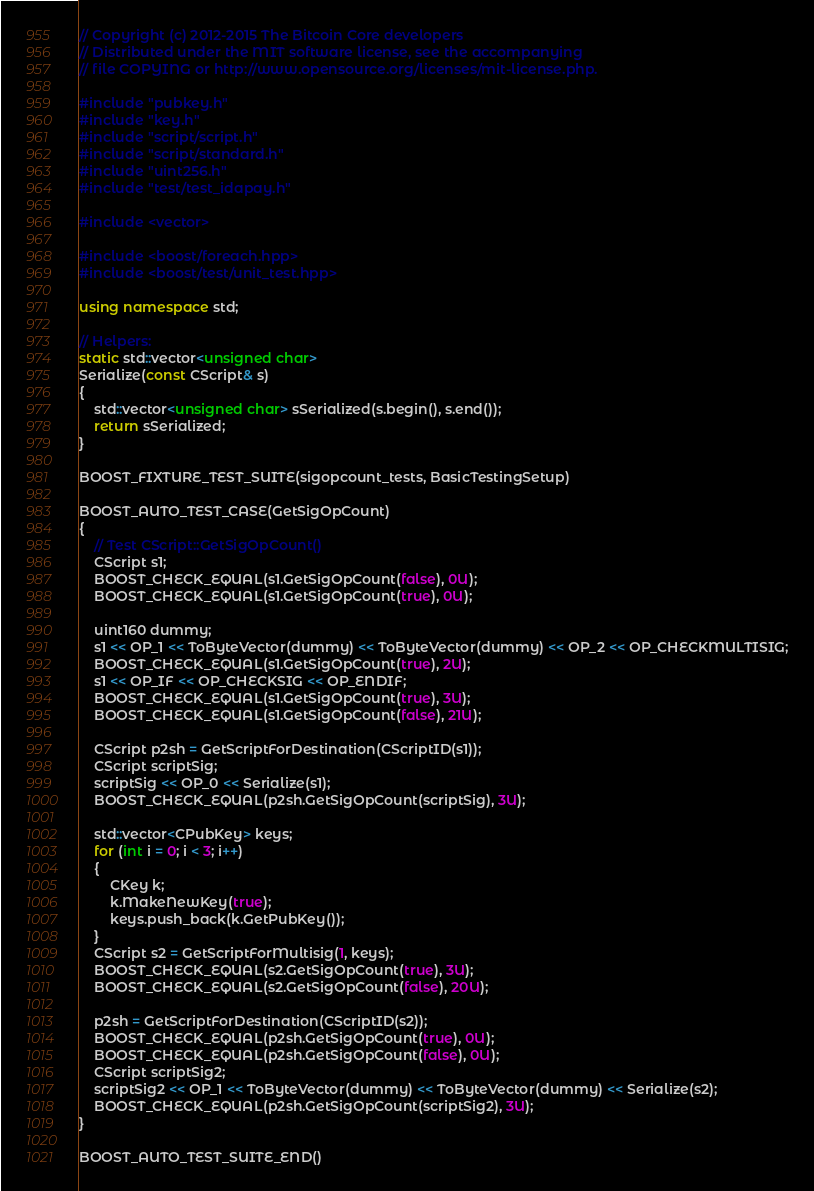Convert code to text. <code><loc_0><loc_0><loc_500><loc_500><_C++_>// Copyright (c) 2012-2015 The Bitcoin Core developers
// Distributed under the MIT software license, see the accompanying
// file COPYING or http://www.opensource.org/licenses/mit-license.php.

#include "pubkey.h"
#include "key.h"
#include "script/script.h"
#include "script/standard.h"
#include "uint256.h"
#include "test/test_idapay.h"

#include <vector>

#include <boost/foreach.hpp>
#include <boost/test/unit_test.hpp>

using namespace std;

// Helpers:
static std::vector<unsigned char>
Serialize(const CScript& s)
{
    std::vector<unsigned char> sSerialized(s.begin(), s.end());
    return sSerialized;
}

BOOST_FIXTURE_TEST_SUITE(sigopcount_tests, BasicTestingSetup)

BOOST_AUTO_TEST_CASE(GetSigOpCount)
{
    // Test CScript::GetSigOpCount()
    CScript s1;
    BOOST_CHECK_EQUAL(s1.GetSigOpCount(false), 0U);
    BOOST_CHECK_EQUAL(s1.GetSigOpCount(true), 0U);

    uint160 dummy;
    s1 << OP_1 << ToByteVector(dummy) << ToByteVector(dummy) << OP_2 << OP_CHECKMULTISIG;
    BOOST_CHECK_EQUAL(s1.GetSigOpCount(true), 2U);
    s1 << OP_IF << OP_CHECKSIG << OP_ENDIF;
    BOOST_CHECK_EQUAL(s1.GetSigOpCount(true), 3U);
    BOOST_CHECK_EQUAL(s1.GetSigOpCount(false), 21U);

    CScript p2sh = GetScriptForDestination(CScriptID(s1));
    CScript scriptSig;
    scriptSig << OP_0 << Serialize(s1);
    BOOST_CHECK_EQUAL(p2sh.GetSigOpCount(scriptSig), 3U);

    std::vector<CPubKey> keys;
    for (int i = 0; i < 3; i++)
    {
        CKey k;
        k.MakeNewKey(true);
        keys.push_back(k.GetPubKey());
    }
    CScript s2 = GetScriptForMultisig(1, keys);
    BOOST_CHECK_EQUAL(s2.GetSigOpCount(true), 3U);
    BOOST_CHECK_EQUAL(s2.GetSigOpCount(false), 20U);

    p2sh = GetScriptForDestination(CScriptID(s2));
    BOOST_CHECK_EQUAL(p2sh.GetSigOpCount(true), 0U);
    BOOST_CHECK_EQUAL(p2sh.GetSigOpCount(false), 0U);
    CScript scriptSig2;
    scriptSig2 << OP_1 << ToByteVector(dummy) << ToByteVector(dummy) << Serialize(s2);
    BOOST_CHECK_EQUAL(p2sh.GetSigOpCount(scriptSig2), 3U);
}

BOOST_AUTO_TEST_SUITE_END()
</code> 